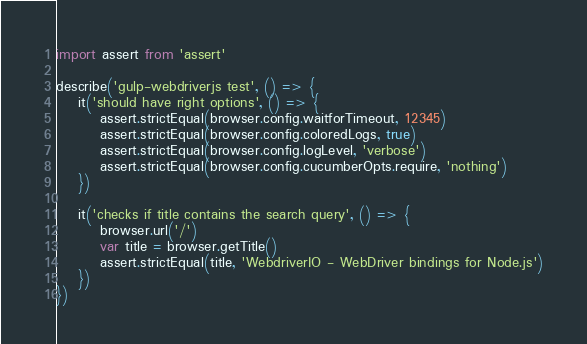<code> <loc_0><loc_0><loc_500><loc_500><_JavaScript_>import assert from 'assert'

describe('gulp-webdriverjs test', () => {
    it('should have right options', () => {
        assert.strictEqual(browser.config.waitforTimeout, 12345)
        assert.strictEqual(browser.config.coloredLogs, true)
        assert.strictEqual(browser.config.logLevel, 'verbose')
        assert.strictEqual(browser.config.cucumberOpts.require, 'nothing')
    })

    it('checks if title contains the search query', () => {
        browser.url('/')
        var title = browser.getTitle()
        assert.strictEqual(title, 'WebdriverIO - WebDriver bindings for Node.js')
    })
})
</code> 